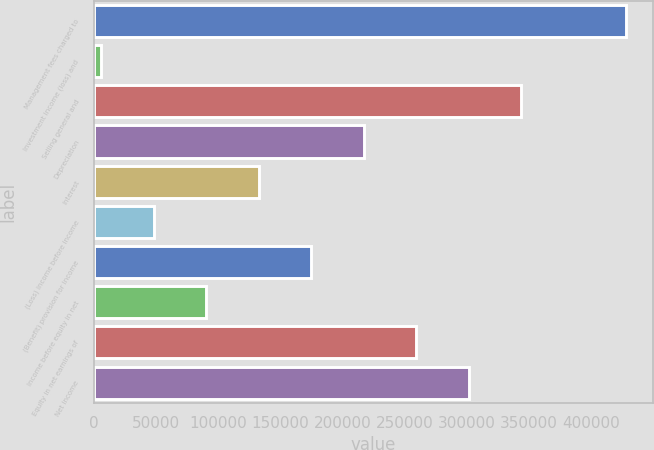Convert chart. <chart><loc_0><loc_0><loc_500><loc_500><bar_chart><fcel>Management fees charged to<fcel>Investment income (loss) and<fcel>Selling general and<fcel>Depreciation<fcel>Interest<fcel>(Loss) income before income<fcel>(Benefit) provision for income<fcel>Income before equity in net<fcel>Equity in net earnings of<fcel>Net income<nl><fcel>428426<fcel>6279<fcel>343997<fcel>217352<fcel>132923<fcel>48493.7<fcel>175138<fcel>90708.4<fcel>259567<fcel>301782<nl></chart> 